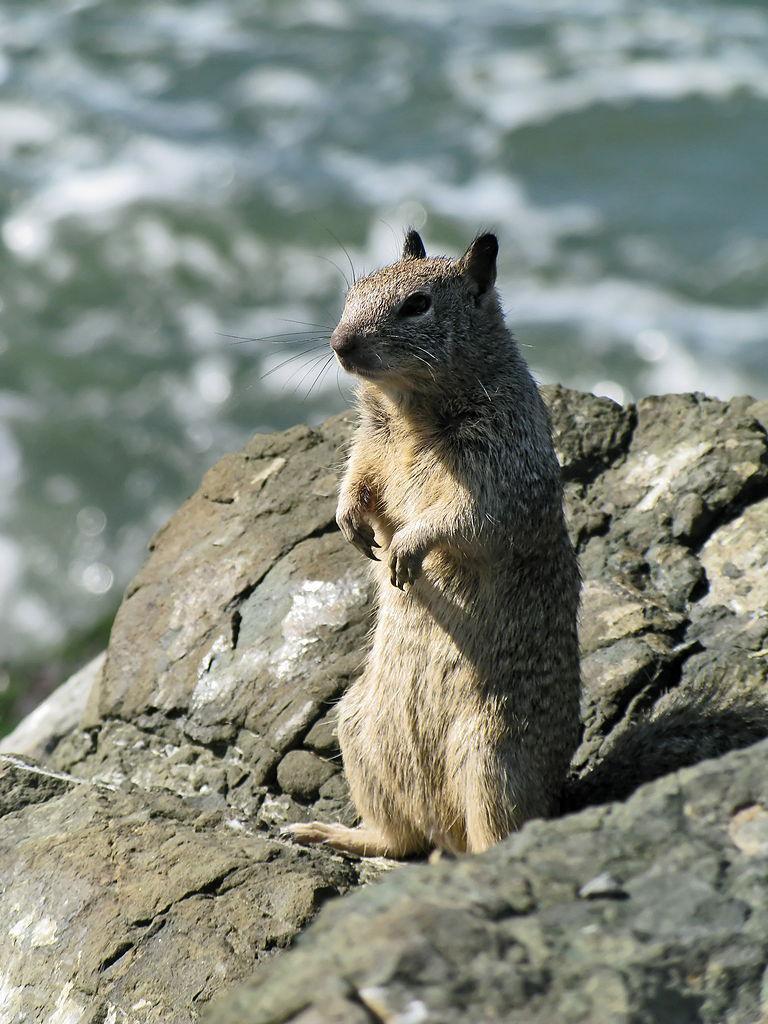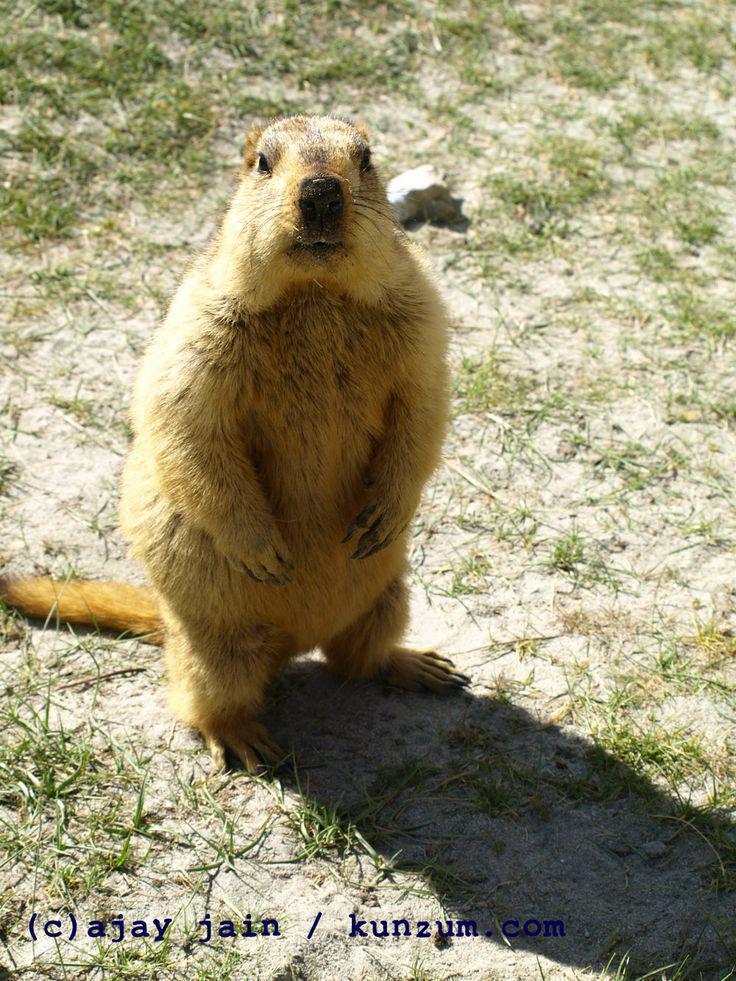The first image is the image on the left, the second image is the image on the right. Examine the images to the left and right. Is the description "Both beavers on the left side are standing up on their hind legs." accurate? Answer yes or no. No. The first image is the image on the left, the second image is the image on the right. For the images displayed, is the sentence "In one of the images there is an animal facing right." factually correct? Answer yes or no. No. 